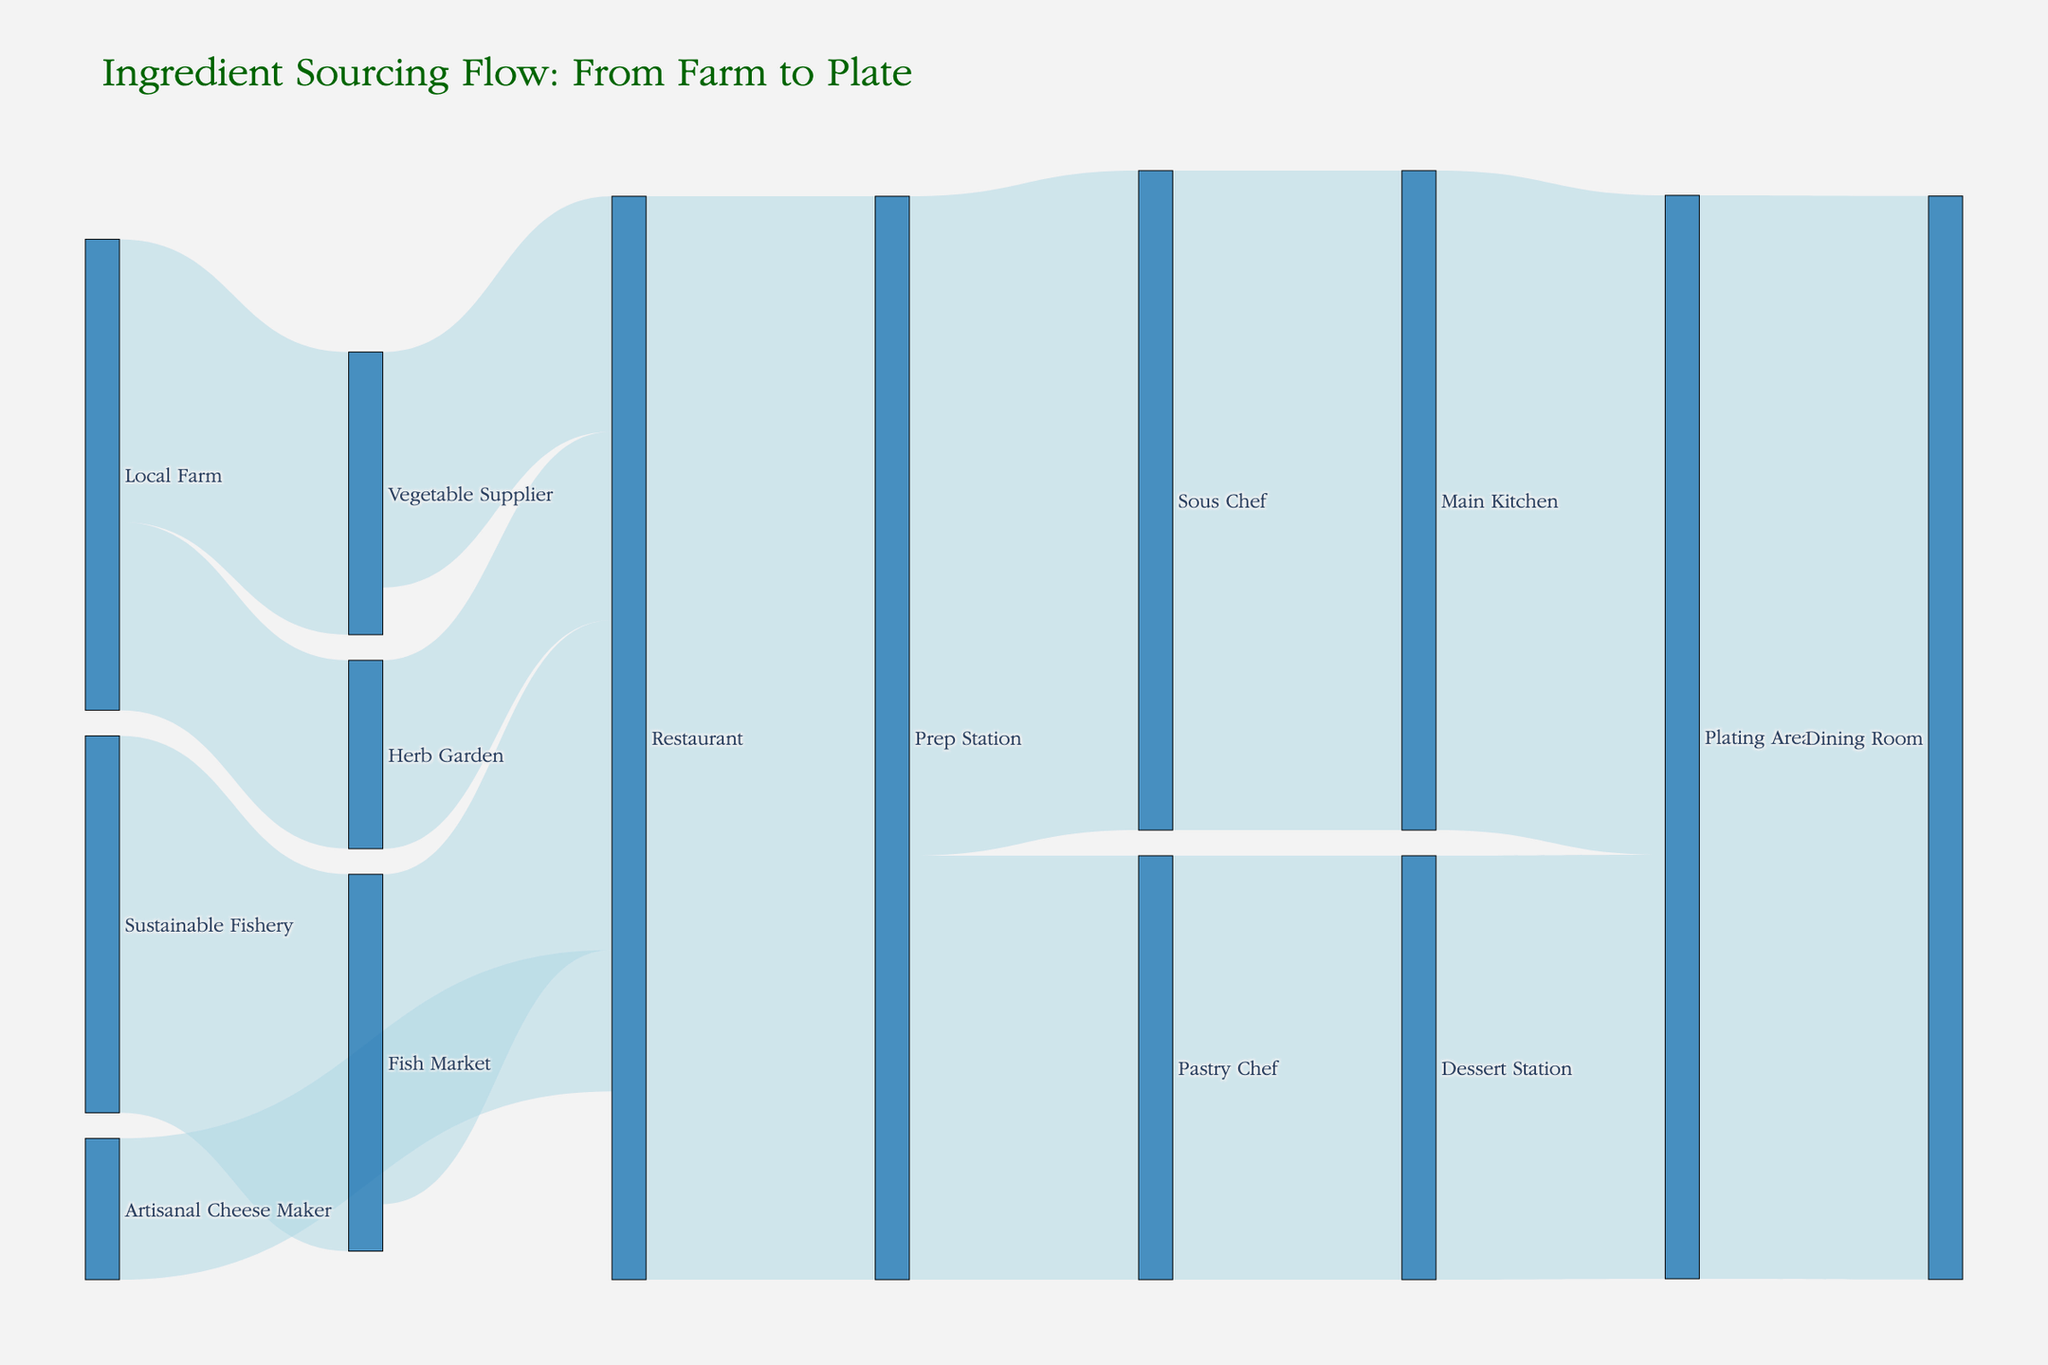What is the title of the figure? The title can be found at the top of the figure, which summarizes the diagram's main information about the flow of ingredients.
Answer: "Ingredient Sourcing Flow: From Farm to Plate" How many sources contribute to the 'Restaurant'? Trace all the links that end at the 'Restaurant' node. The sources are ‘Herb Garden’, ‘Vegetable Supplier’, ‘Fish Market’, and ‘Artisanal Cheese Maker’.
Answer: Four sources Which destination receives the largest value from its source? Look at all targets and identify the one receiving the highest value from any of its sources. The 'Prep Station' receives 115 from the 'Restaurant'.
Answer: Prep Station What are the intermediate steps between 'Sous Chef' and 'Dining Room'? Follow the path starting from 'Sous Chef' to the concluding 'Dining Room' node. It goes through 'Main Kitchen' and 'Plating Area'.
Answer: Main Kitchen, Plating Area How much total value does the 'Vegetable Supplier' handle? Sum all the values directed to and from the 'Vegetable Supplier'. It only sends 25 to 'Restaurant' and receives 30 from 'Local Farm'.
Answer: 30 Which nodes have only one outgoing link? Identify nodes that are sources with exactly one outgoing link. These are 'Artisanal Cheese Maker', 'Herb Garden', 'Sous Chef', 'Pastry Chef', 'Main Kitchen', 'Dessert Station', 'Plating Area'.
Answer: Seven nodes What is the difference between the value received by 'Pastry Chef' and the value received by 'Sous Chef'? Subtract the value directed to 'Sous Chef' from the value directed to 'Pastry Chef' (70 - 45).
Answer: 25 Which node has the highest total incoming value, and what is it? Add up all values directed into each node and identify the node with the highest sum. 'Prep Station' has a total incoming of 115.
Answer: Prep Station - 115 How many total values flow into the 'Dining Room'? Follow the total values inflain into 'Dining Room' from the 'Plating Area', which is the final step. Summing the value into 'Dining Room' is 115.
Answer: 115 Are there any nodes that do not send out any values? Look for nodes that are only targets and do not act as sources. The 'Dining Room' node has no outgoing links.
Answer: One node 